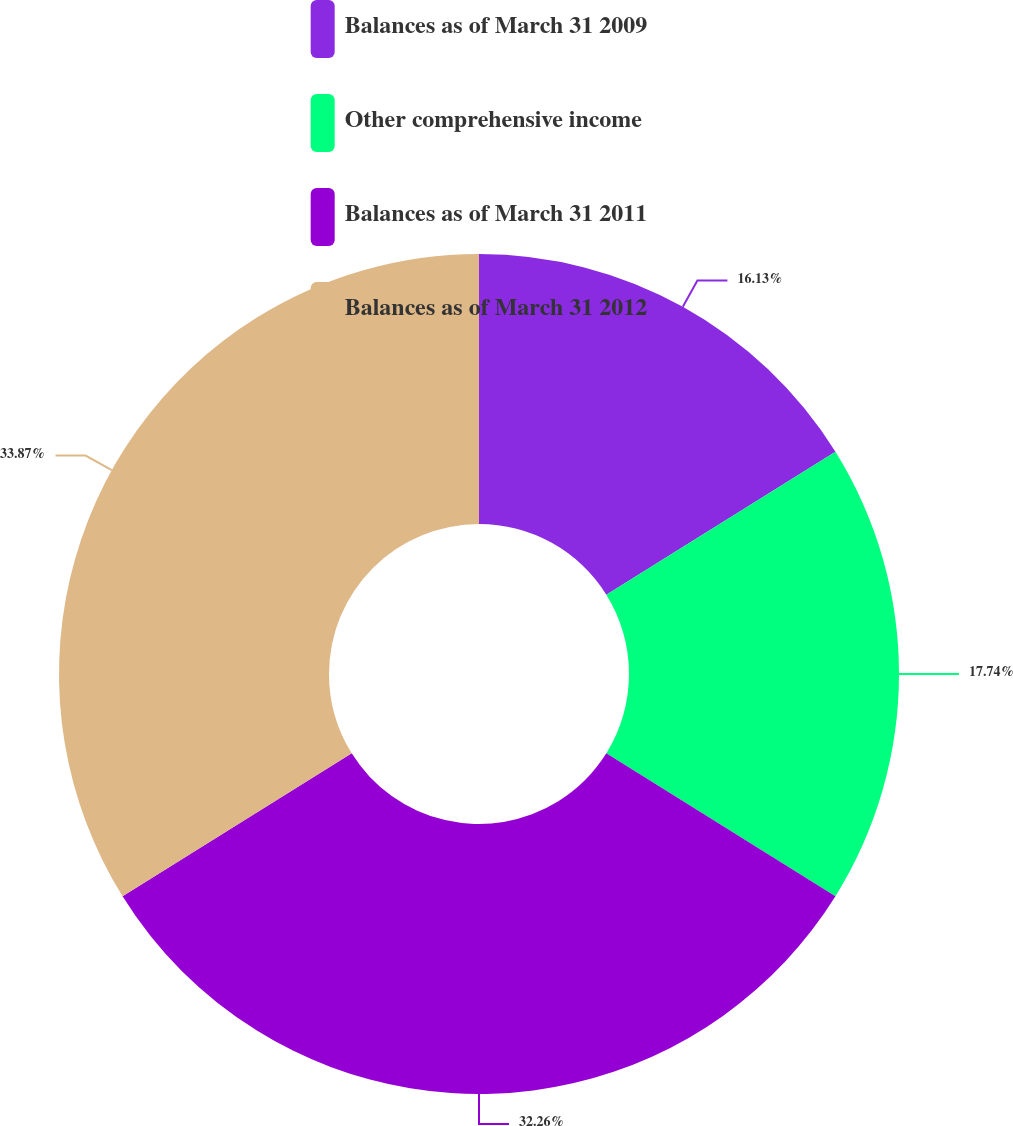Convert chart to OTSL. <chart><loc_0><loc_0><loc_500><loc_500><pie_chart><fcel>Balances as of March 31 2009<fcel>Other comprehensive income<fcel>Balances as of March 31 2011<fcel>Balances as of March 31 2012<nl><fcel>16.13%<fcel>17.74%<fcel>32.26%<fcel>33.87%<nl></chart> 